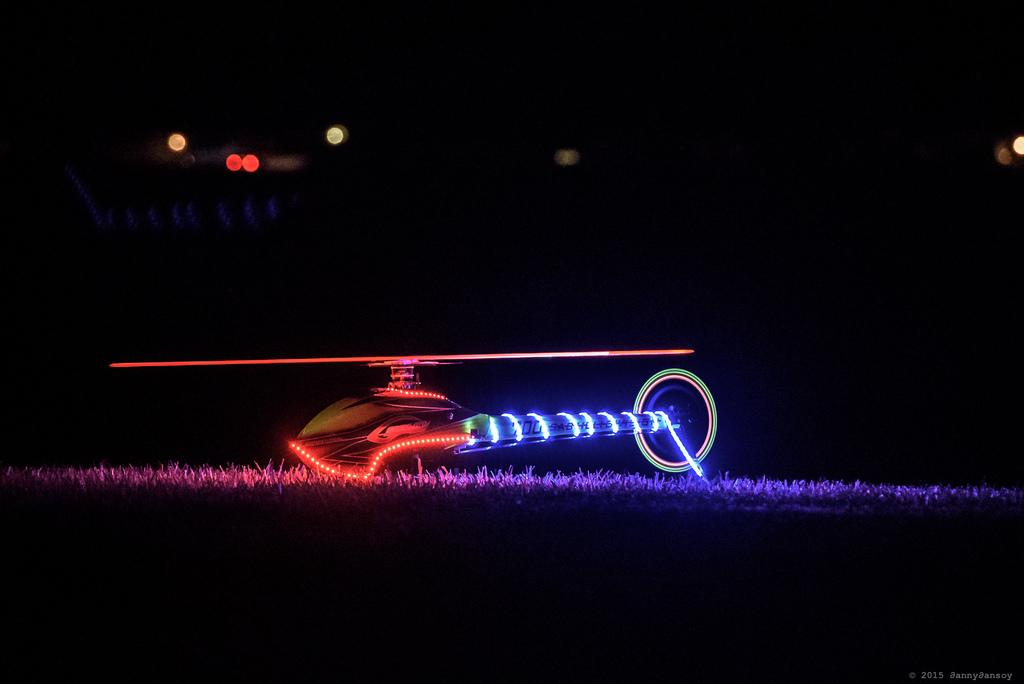What type of vehicle is on the ground in the image? There is a helicopter on the ground in the image. What type of vegetation can be seen in the image? There is grass visible in the image. What can be seen in the image that might provide illumination? There are lights in the image. How would you describe the overall lighting in the image? The background of the image appears to be dark. What type of pipe is visible in the image? There is no pipe present in the image. What type of sheet is covering the helicopter in the image? There is no sheet covering the helicopter in the image. 